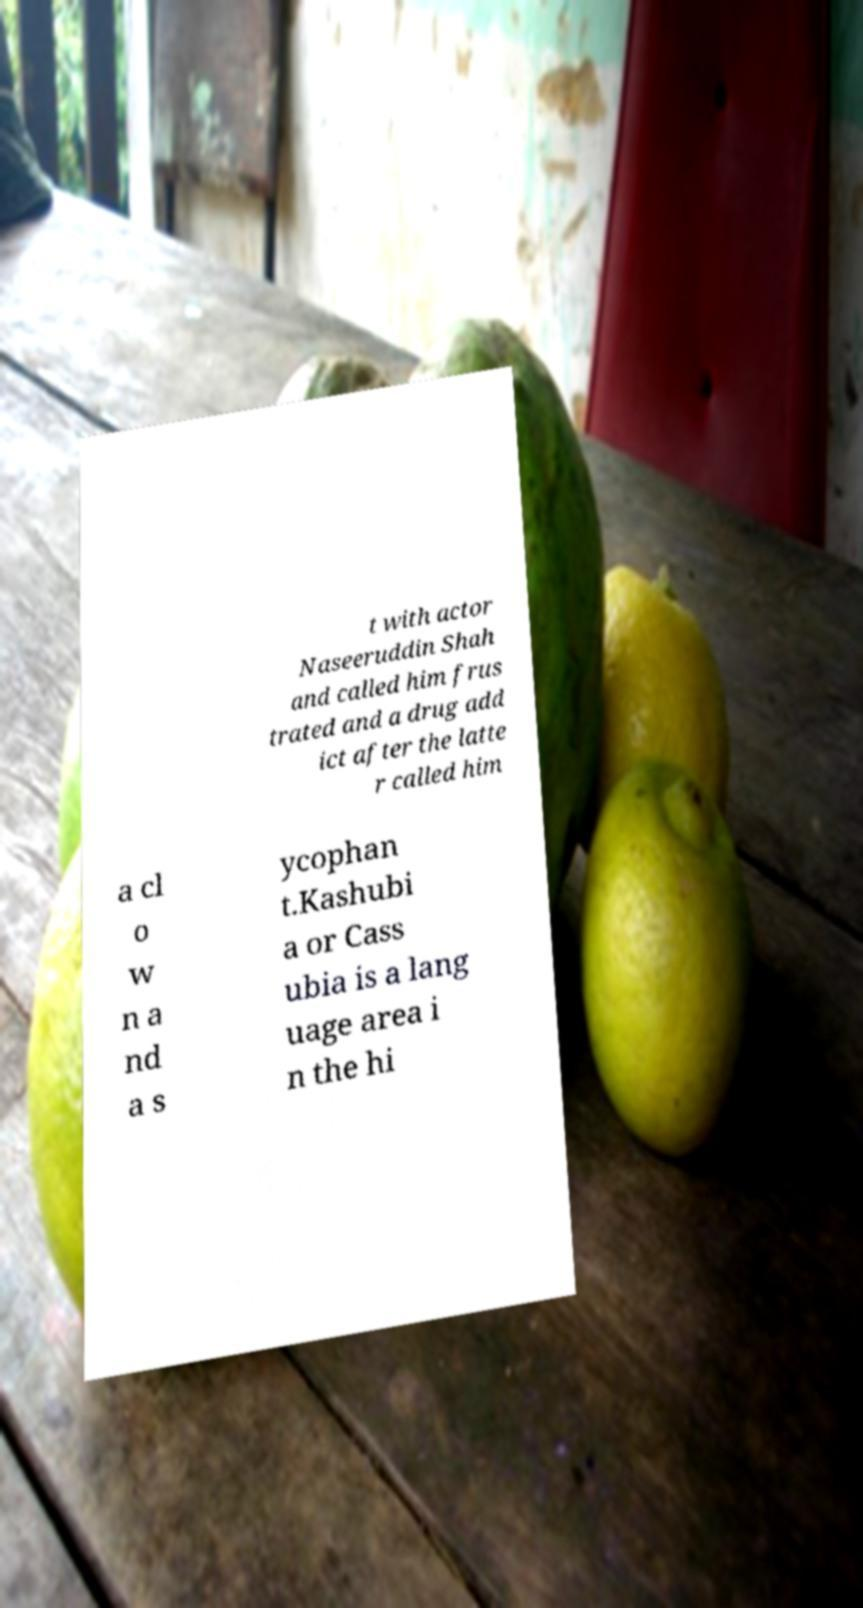Could you extract and type out the text from this image? t with actor Naseeruddin Shah and called him frus trated and a drug add ict after the latte r called him a cl o w n a nd a s ycophan t.Kashubi a or Cass ubia is a lang uage area i n the hi 